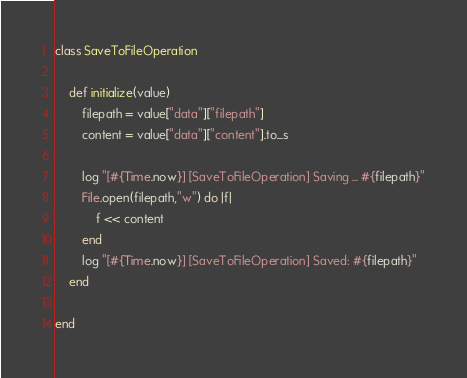Convert code to text. <code><loc_0><loc_0><loc_500><loc_500><_Ruby_>class SaveToFileOperation

    def initialize(value)
        filepath = value["data"]["filepath"]
        content = value["data"]["content"].to_s

        log "[#{Time.now}] [SaveToFileOperation] Saving ... #{filepath}"
        File.open(filepath,"w") do |f|
            f << content
        end
        log "[#{Time.now}] [SaveToFileOperation] Saved: #{filepath}"
    end

end</code> 